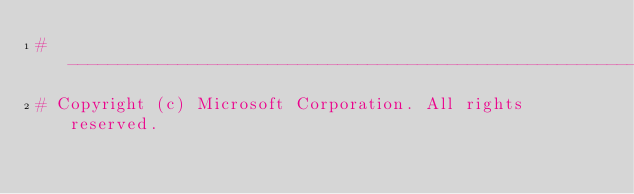Convert code to text. <code><loc_0><loc_0><loc_500><loc_500><_Python_># -------------------------------------------------------------------------
# Copyright (c) Microsoft Corporation. All rights reserved.</code> 